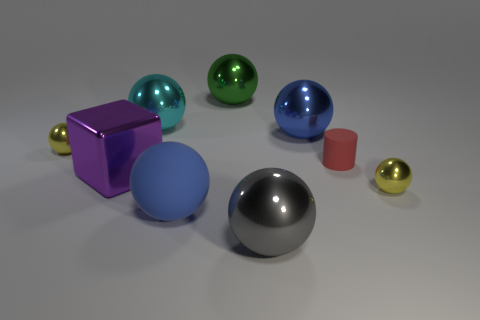What is the material of the object that is the same color as the large rubber sphere?
Give a very brief answer. Metal. What number of other objects are the same size as the cyan object?
Offer a very short reply. 5. There is a metallic ball right of the big blue metallic ball; is it the same size as the yellow ball that is behind the red object?
Offer a very short reply. Yes. The small object on the left side of the large purple metallic cube has what shape?
Your answer should be compact. Sphere. There is a large blue object in front of the small yellow shiny object that is to the right of the big gray metallic sphere; what is it made of?
Your response must be concise. Rubber. Is there a big shiny ball of the same color as the rubber ball?
Provide a short and direct response. Yes. Do the gray ball and the yellow metallic thing to the left of the large blue metallic thing have the same size?
Give a very brief answer. No. How many big blue balls are behind the yellow metal thing that is right of the yellow shiny sphere that is behind the tiny red cylinder?
Your response must be concise. 1. There is a large cyan object; what number of large shiny spheres are in front of it?
Your answer should be compact. 2. What is the color of the big metallic object in front of the large blue thing that is left of the large blue metal thing?
Your answer should be very brief. Gray. 